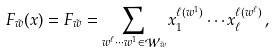Convert formula to latex. <formula><loc_0><loc_0><loc_500><loc_500>F _ { \tilde { w } } ( x ) = F _ { \tilde { w } } = \sum _ { w ^ { \ell } \cdots w ^ { 1 } \in \mathcal { W } _ { \tilde { w } } } x _ { 1 } ^ { \ell ( w ^ { 1 } ) } \cdots x _ { \ell } ^ { \ell ( w ^ { \ell } ) } \, ,</formula> 